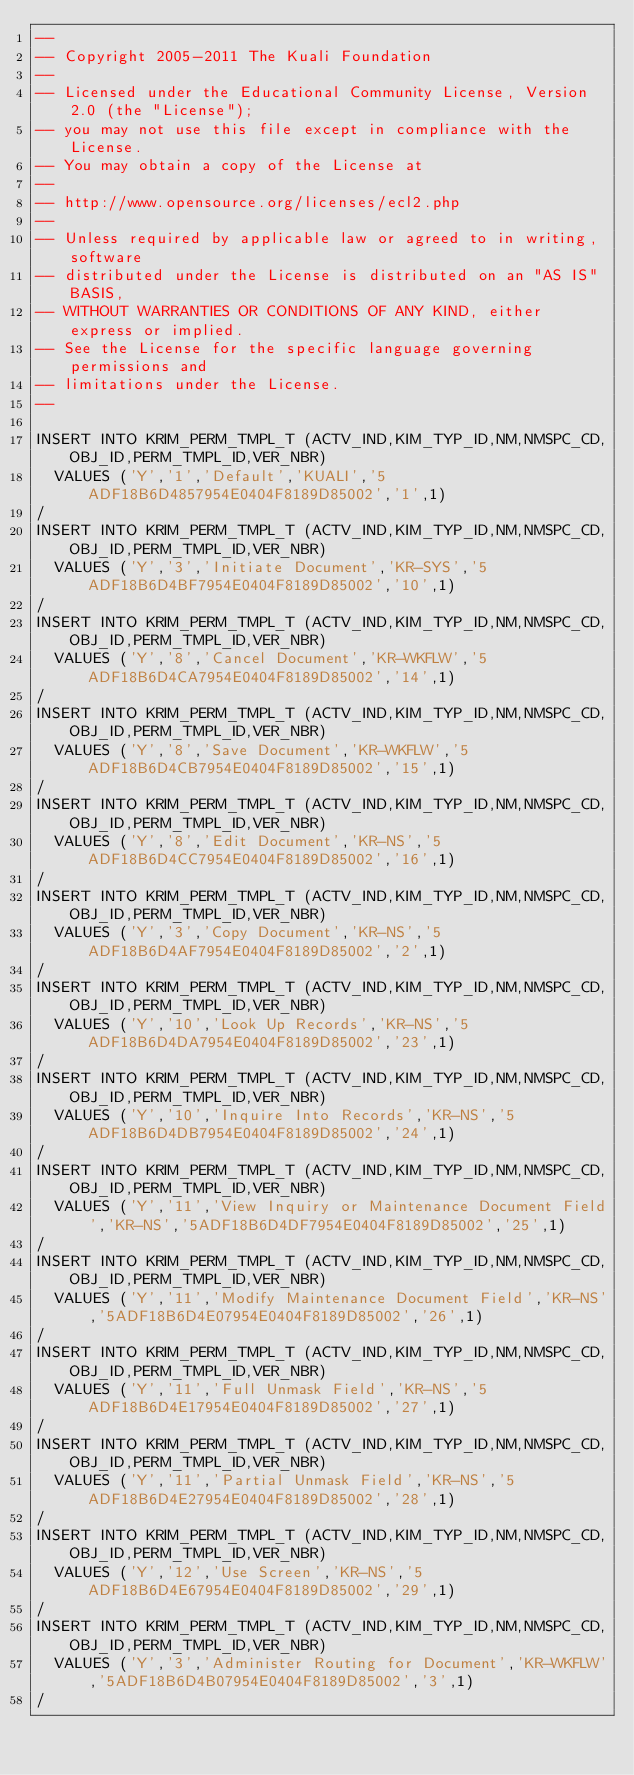Convert code to text. <code><loc_0><loc_0><loc_500><loc_500><_SQL_>--
-- Copyright 2005-2011 The Kuali Foundation
--
-- Licensed under the Educational Community License, Version 2.0 (the "License");
-- you may not use this file except in compliance with the License.
-- You may obtain a copy of the License at
--
-- http://www.opensource.org/licenses/ecl2.php
--
-- Unless required by applicable law or agreed to in writing, software
-- distributed under the License is distributed on an "AS IS" BASIS,
-- WITHOUT WARRANTIES OR CONDITIONS OF ANY KIND, either express or implied.
-- See the License for the specific language governing permissions and
-- limitations under the License.
--

INSERT INTO KRIM_PERM_TMPL_T (ACTV_IND,KIM_TYP_ID,NM,NMSPC_CD,OBJ_ID,PERM_TMPL_ID,VER_NBR)
  VALUES ('Y','1','Default','KUALI','5ADF18B6D4857954E0404F8189D85002','1',1)
/
INSERT INTO KRIM_PERM_TMPL_T (ACTV_IND,KIM_TYP_ID,NM,NMSPC_CD,OBJ_ID,PERM_TMPL_ID,VER_NBR)
  VALUES ('Y','3','Initiate Document','KR-SYS','5ADF18B6D4BF7954E0404F8189D85002','10',1)
/
INSERT INTO KRIM_PERM_TMPL_T (ACTV_IND,KIM_TYP_ID,NM,NMSPC_CD,OBJ_ID,PERM_TMPL_ID,VER_NBR)
  VALUES ('Y','8','Cancel Document','KR-WKFLW','5ADF18B6D4CA7954E0404F8189D85002','14',1)
/
INSERT INTO KRIM_PERM_TMPL_T (ACTV_IND,KIM_TYP_ID,NM,NMSPC_CD,OBJ_ID,PERM_TMPL_ID,VER_NBR)
  VALUES ('Y','8','Save Document','KR-WKFLW','5ADF18B6D4CB7954E0404F8189D85002','15',1)
/
INSERT INTO KRIM_PERM_TMPL_T (ACTV_IND,KIM_TYP_ID,NM,NMSPC_CD,OBJ_ID,PERM_TMPL_ID,VER_NBR)
  VALUES ('Y','8','Edit Document','KR-NS','5ADF18B6D4CC7954E0404F8189D85002','16',1)
/
INSERT INTO KRIM_PERM_TMPL_T (ACTV_IND,KIM_TYP_ID,NM,NMSPC_CD,OBJ_ID,PERM_TMPL_ID,VER_NBR)
  VALUES ('Y','3','Copy Document','KR-NS','5ADF18B6D4AF7954E0404F8189D85002','2',1)
/
INSERT INTO KRIM_PERM_TMPL_T (ACTV_IND,KIM_TYP_ID,NM,NMSPC_CD,OBJ_ID,PERM_TMPL_ID,VER_NBR)
  VALUES ('Y','10','Look Up Records','KR-NS','5ADF18B6D4DA7954E0404F8189D85002','23',1)
/
INSERT INTO KRIM_PERM_TMPL_T (ACTV_IND,KIM_TYP_ID,NM,NMSPC_CD,OBJ_ID,PERM_TMPL_ID,VER_NBR)
  VALUES ('Y','10','Inquire Into Records','KR-NS','5ADF18B6D4DB7954E0404F8189D85002','24',1)
/
INSERT INTO KRIM_PERM_TMPL_T (ACTV_IND,KIM_TYP_ID,NM,NMSPC_CD,OBJ_ID,PERM_TMPL_ID,VER_NBR)
  VALUES ('Y','11','View Inquiry or Maintenance Document Field','KR-NS','5ADF18B6D4DF7954E0404F8189D85002','25',1)
/
INSERT INTO KRIM_PERM_TMPL_T (ACTV_IND,KIM_TYP_ID,NM,NMSPC_CD,OBJ_ID,PERM_TMPL_ID,VER_NBR)
  VALUES ('Y','11','Modify Maintenance Document Field','KR-NS','5ADF18B6D4E07954E0404F8189D85002','26',1)
/
INSERT INTO KRIM_PERM_TMPL_T (ACTV_IND,KIM_TYP_ID,NM,NMSPC_CD,OBJ_ID,PERM_TMPL_ID,VER_NBR)
  VALUES ('Y','11','Full Unmask Field','KR-NS','5ADF18B6D4E17954E0404F8189D85002','27',1)
/
INSERT INTO KRIM_PERM_TMPL_T (ACTV_IND,KIM_TYP_ID,NM,NMSPC_CD,OBJ_ID,PERM_TMPL_ID,VER_NBR)
  VALUES ('Y','11','Partial Unmask Field','KR-NS','5ADF18B6D4E27954E0404F8189D85002','28',1)
/
INSERT INTO KRIM_PERM_TMPL_T (ACTV_IND,KIM_TYP_ID,NM,NMSPC_CD,OBJ_ID,PERM_TMPL_ID,VER_NBR)
  VALUES ('Y','12','Use Screen','KR-NS','5ADF18B6D4E67954E0404F8189D85002','29',1)
/
INSERT INTO KRIM_PERM_TMPL_T (ACTV_IND,KIM_TYP_ID,NM,NMSPC_CD,OBJ_ID,PERM_TMPL_ID,VER_NBR)
  VALUES ('Y','3','Administer Routing for Document','KR-WKFLW','5ADF18B6D4B07954E0404F8189D85002','3',1)
/</code> 